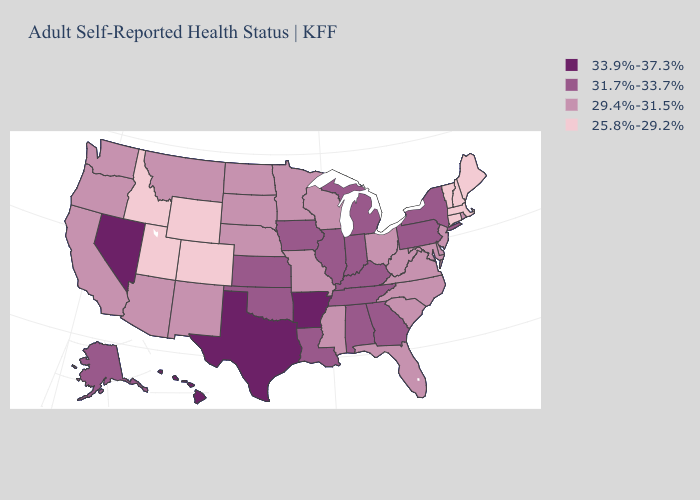Among the states that border South Dakota , does Wyoming have the lowest value?
Be succinct. Yes. Name the states that have a value in the range 25.8%-29.2%?
Concise answer only. Colorado, Connecticut, Idaho, Maine, Massachusetts, New Hampshire, Utah, Vermont, Wyoming. Does Montana have the same value as Pennsylvania?
Keep it brief. No. What is the lowest value in the USA?
Give a very brief answer. 25.8%-29.2%. Which states have the lowest value in the USA?
Give a very brief answer. Colorado, Connecticut, Idaho, Maine, Massachusetts, New Hampshire, Utah, Vermont, Wyoming. Does the map have missing data?
Be succinct. No. How many symbols are there in the legend?
Concise answer only. 4. Which states have the lowest value in the West?
Concise answer only. Colorado, Idaho, Utah, Wyoming. What is the value of Missouri?
Give a very brief answer. 29.4%-31.5%. Is the legend a continuous bar?
Quick response, please. No. Name the states that have a value in the range 31.7%-33.7%?
Answer briefly. Alabama, Alaska, Georgia, Illinois, Indiana, Iowa, Kansas, Kentucky, Louisiana, Michigan, New York, Oklahoma, Pennsylvania, Tennessee. Among the states that border Illinois , does Missouri have the lowest value?
Answer briefly. Yes. Name the states that have a value in the range 33.9%-37.3%?
Be succinct. Arkansas, Hawaii, Nevada, Texas. What is the value of Ohio?
Quick response, please. 29.4%-31.5%. What is the highest value in the USA?
Keep it brief. 33.9%-37.3%. 